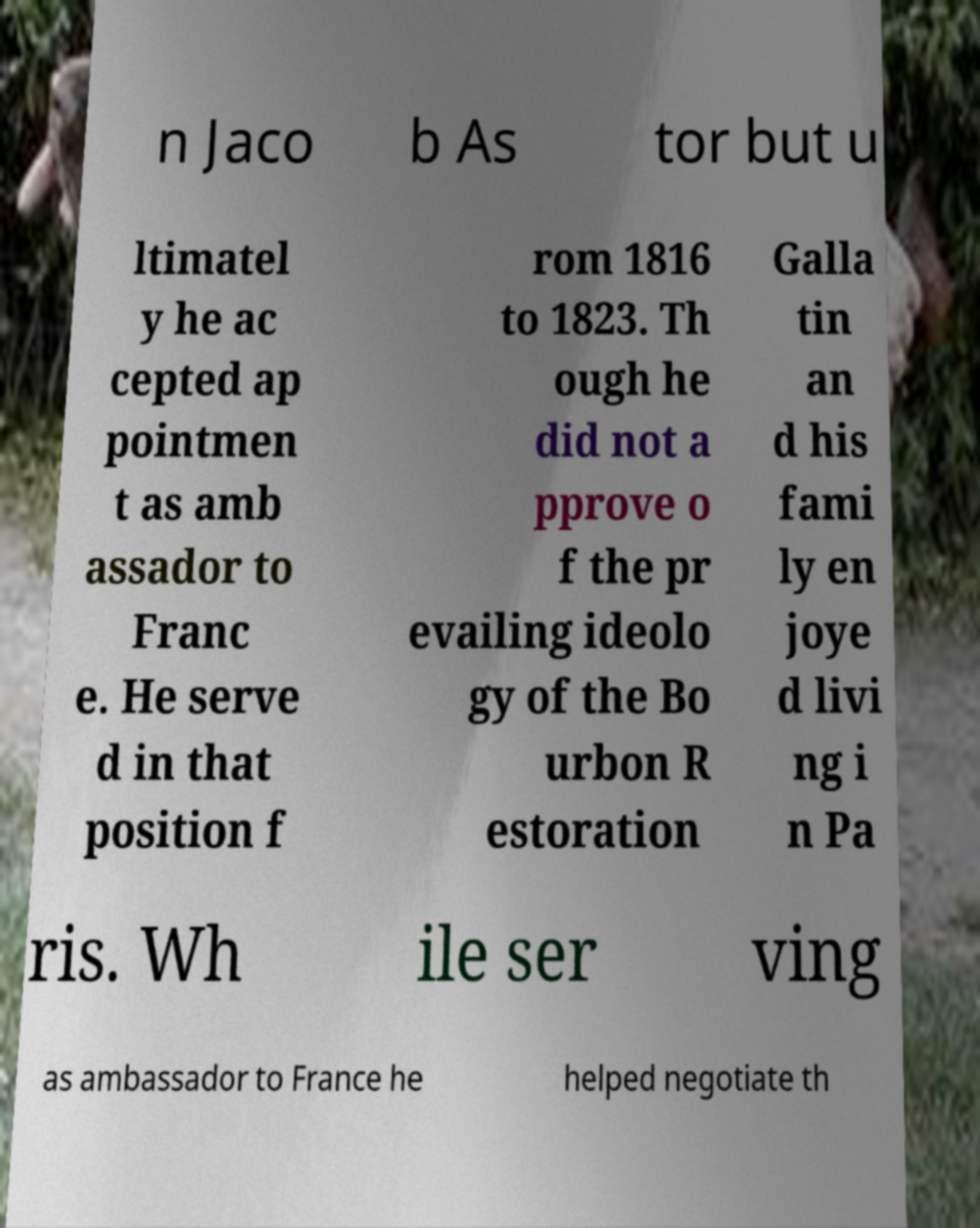Please identify and transcribe the text found in this image. n Jaco b As tor but u ltimatel y he ac cepted ap pointmen t as amb assador to Franc e. He serve d in that position f rom 1816 to 1823. Th ough he did not a pprove o f the pr evailing ideolo gy of the Bo urbon R estoration Galla tin an d his fami ly en joye d livi ng i n Pa ris. Wh ile ser ving as ambassador to France he helped negotiate th 